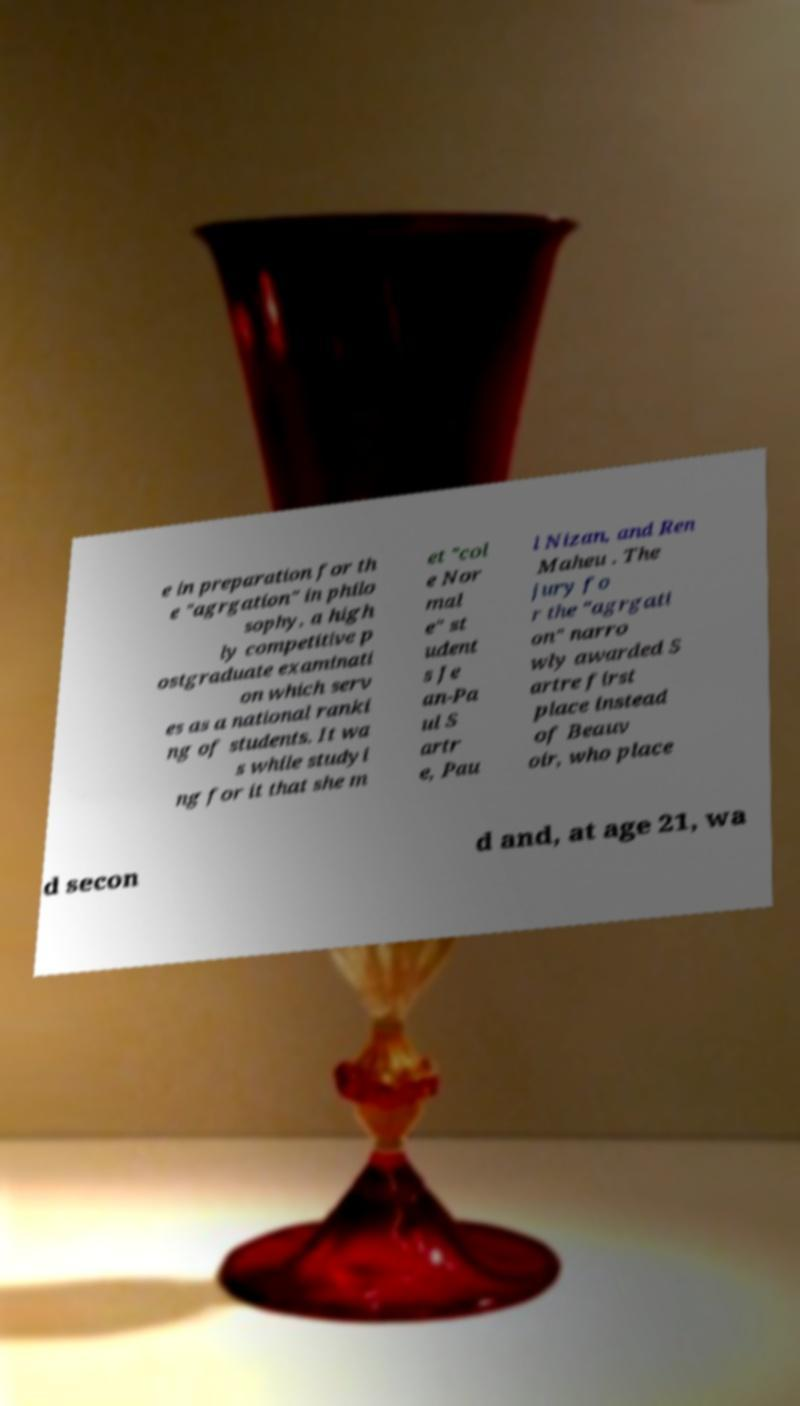Please read and relay the text visible in this image. What does it say? e in preparation for th e "agrgation" in philo sophy, a high ly competitive p ostgraduate examinati on which serv es as a national ranki ng of students. It wa s while studyi ng for it that she m et "col e Nor mal e" st udent s Je an-Pa ul S artr e, Pau l Nizan, and Ren Maheu . The jury fo r the "agrgati on" narro wly awarded S artre first place instead of Beauv oir, who place d secon d and, at age 21, wa 